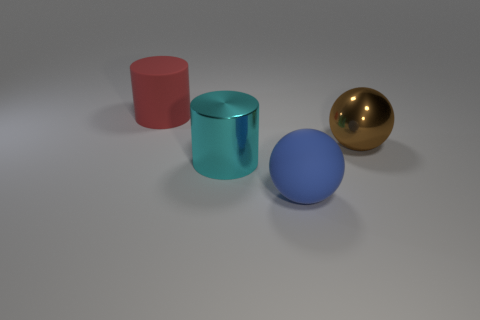Subtract 1 cylinders. How many cylinders are left? 1 Add 4 big blue rubber balls. How many objects exist? 8 Subtract all brown balls. How many cyan cylinders are left? 1 Subtract all purple cylinders. Subtract all blue balls. How many cylinders are left? 2 Subtract all rubber cylinders. Subtract all big red shiny things. How many objects are left? 3 Add 2 large blue matte balls. How many large blue matte balls are left? 3 Add 2 matte things. How many matte things exist? 4 Subtract 0 red blocks. How many objects are left? 4 